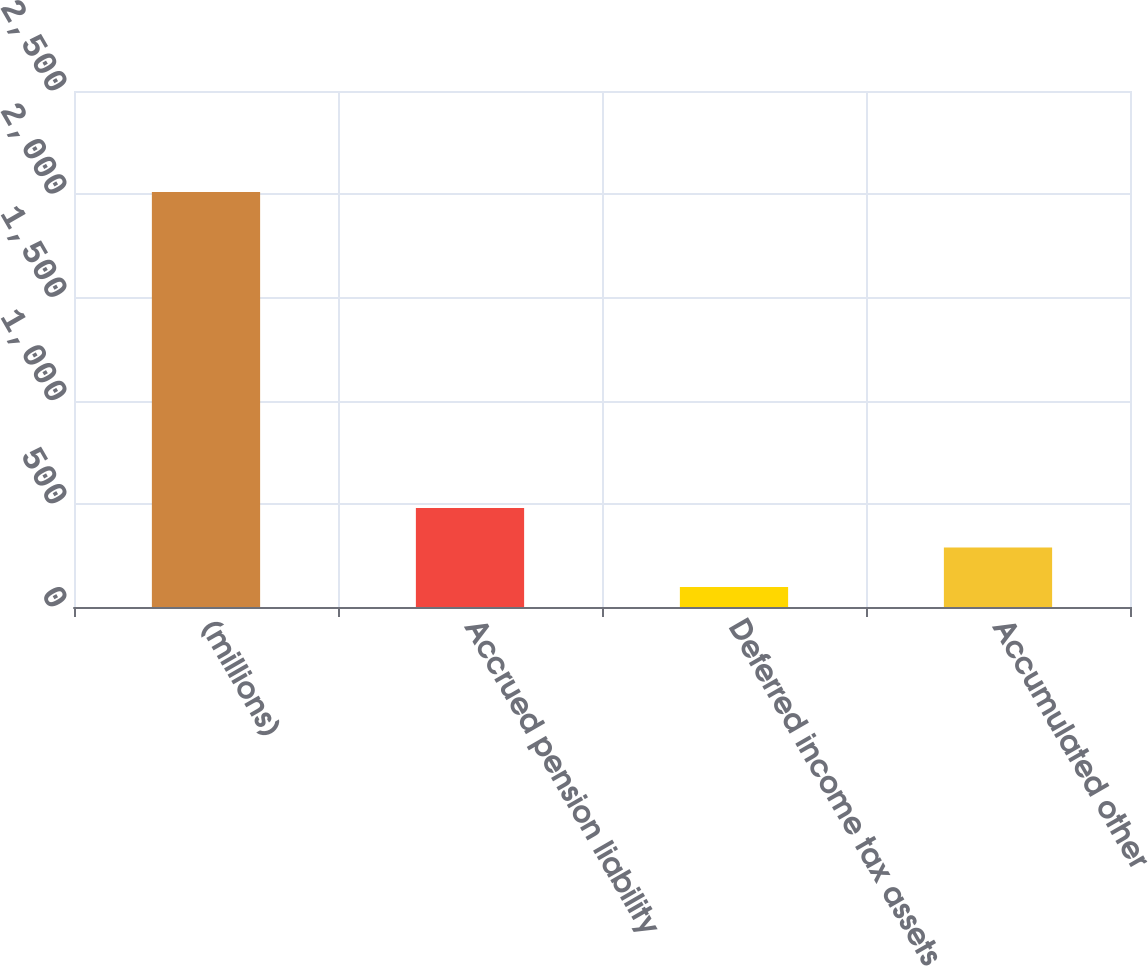<chart> <loc_0><loc_0><loc_500><loc_500><bar_chart><fcel>(millions)<fcel>Accrued pension liability<fcel>Deferred income tax assets<fcel>Accumulated other<nl><fcel>2011<fcel>479.88<fcel>97.1<fcel>288.49<nl></chart> 